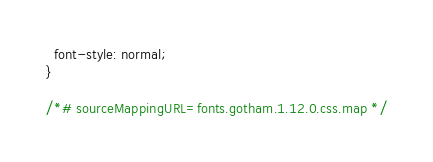<code> <loc_0><loc_0><loc_500><loc_500><_CSS_>  font-style: normal;
}

/*# sourceMappingURL=fonts.gotham.1.12.0.css.map */
</code> 